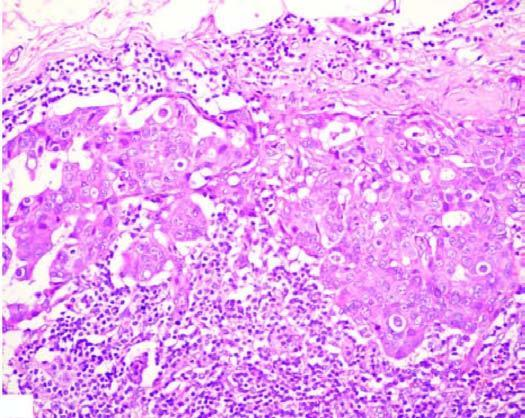s gram 's surrounded by increased fat?
Answer the question using a single word or phrase. No 